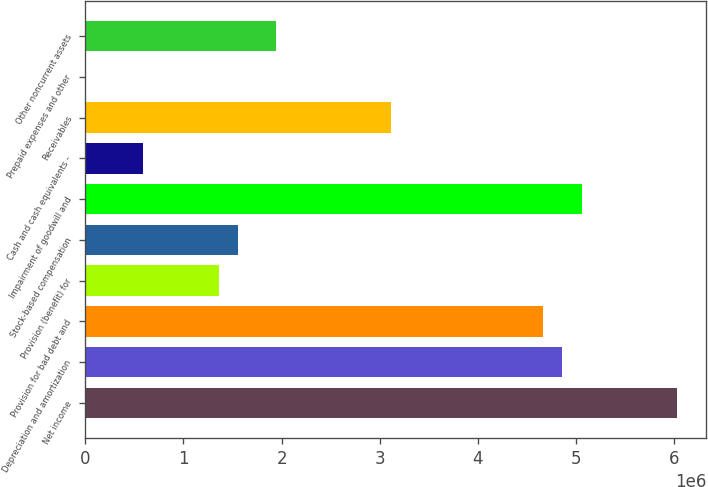Convert chart to OTSL. <chart><loc_0><loc_0><loc_500><loc_500><bar_chart><fcel>Net income<fcel>Depreciation and amortization<fcel>Provision for bad debt and<fcel>Provision (benefit) for<fcel>Stock-based compensation<fcel>Impairment of goodwill and<fcel>Cash and cash equivalents -<fcel>Receivables<fcel>Prepaid expenses and other<fcel>Other noncurrent assets<nl><fcel>6.02631e+06<fcel>4.86003e+06<fcel>4.66565e+06<fcel>1.3612e+06<fcel>1.55557e+06<fcel>5.05441e+06<fcel>583677<fcel>3.11061e+06<fcel>538<fcel>1.94433e+06<nl></chart> 